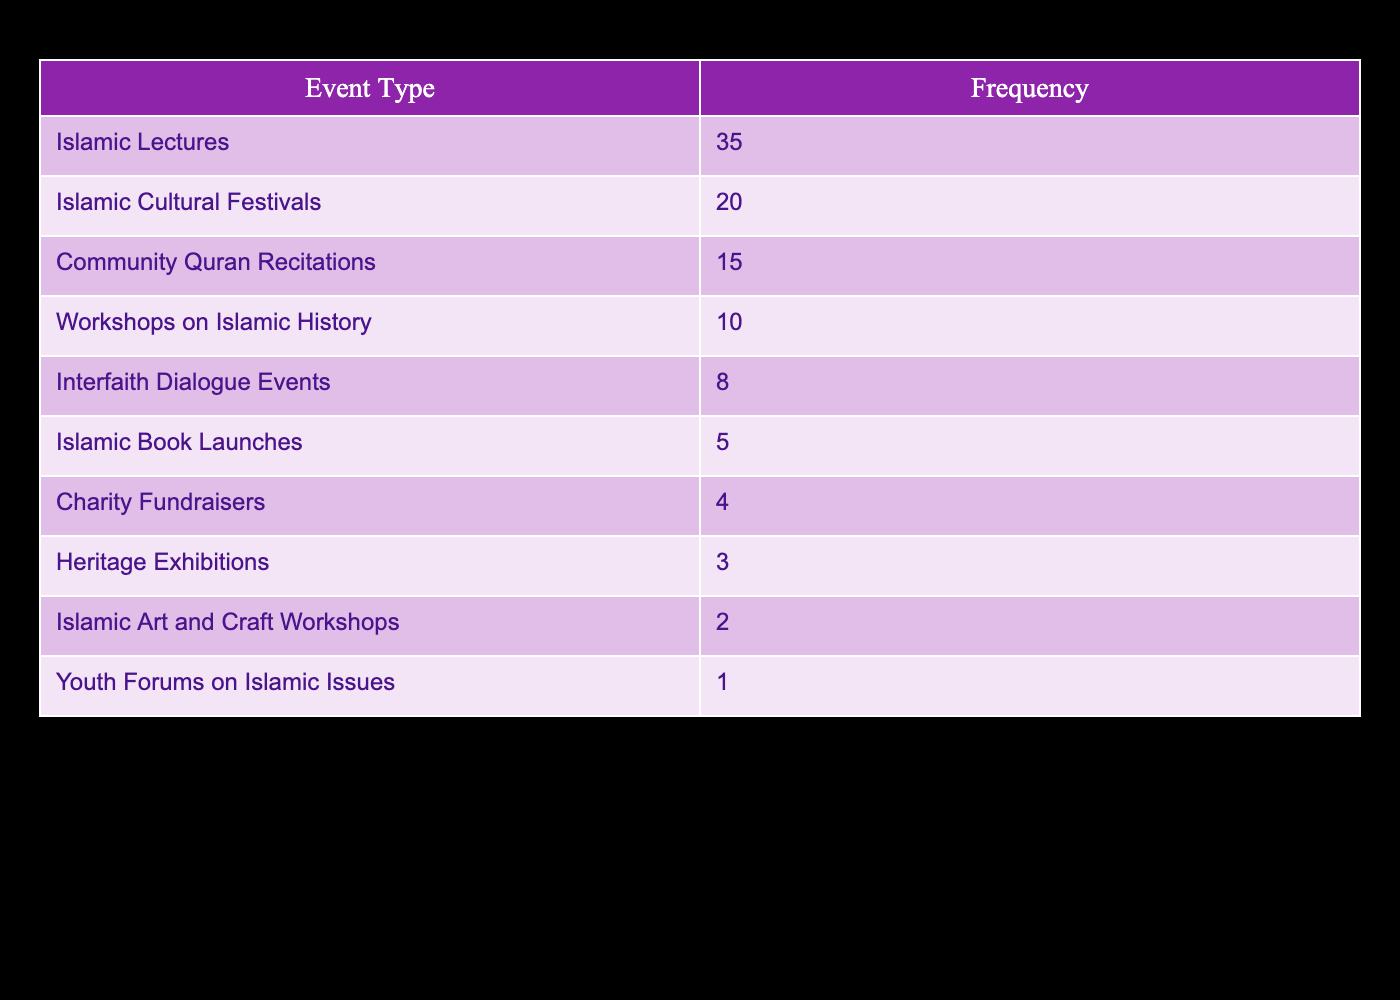What is the frequency of Islamic Lectures attended by community members? The table indicates that the frequency of Islamic Lectures is listed directly under the "Frequency" column when looking at the corresponding "Event Type." It shows that 35 members attended these lectures.
Answer: 35 What is the total frequency of all events combined? To find the total frequency, we need to sum all the frequencies: 35 (Islamic Lectures) + 20 (Islamic Cultural Festivals) + 15 (Community Quran Recitations) + 10 (Workshops on Islamic History) + 8 (Interfaith Dialogue Events) + 5 (Islamic Book Launches) + 4 (Charity Fundraisers) + 3 (Heritage Exhibitions) + 2 (Islamic Art and Craft Workshops) + 1 (Youth Forums on Islamic Issues) = 109.
Answer: 109 Are there more attendees at Islamic Cultural Festivals than at Community Quran Recitations? From the table, Islamic Cultural Festivals have a frequency of 20, while Community Quran Recitations have 15. Since 20 is greater than 15, the answer is yes.
Answer: Yes What percentage of the total events does the frequency of Charity Fundraisers represent? First, we calculate the total frequency, which is 109. Next, the frequency of Charity Fundraisers is 4. To find the percentage, we use the formula (Frequency of Charity Fundraisers / Total Frequency) * 100 = (4 / 109) * 100, which is approximately 3.67%.
Answer: Approximately 3.67% How many more people attended Islamic Lectures than Islamic Book Launches? The frequency of Islamic Lectures is 35 and the frequency of Islamic Book Launches is 5. We subtract the two: 35 - 5 = 30 more people attended Islamic Lectures.
Answer: 30 What is the median frequency of events attended? First, we list the frequencies in order: 1, 2, 3, 4, 5, 8, 10, 15, 20, 35. There are 10 frequencies (an even number), so we take the middle two numbers: 5 and 8. We find the median by calculating the average: (5 + 8) / 2 = 6.5.
Answer: 6.5 Is it true that there were fewer Islamic Art and Craft Workshops than Heritage Exhibitions attended? The frequency of Islamic Art and Craft Workshops is 2, while Heritage Exhibitions has a frequency of 3. As 2 is less than 3, the statement is true.
Answer: True Which two types of events had the least attendance, and what was their combined frequency? From the table, the two events with the least attendance are Islamic Art and Craft Workshops (2) and Youth Forums on Islamic Issues (1). We add their frequencies: 2 + 1 = 3.
Answer: 3 